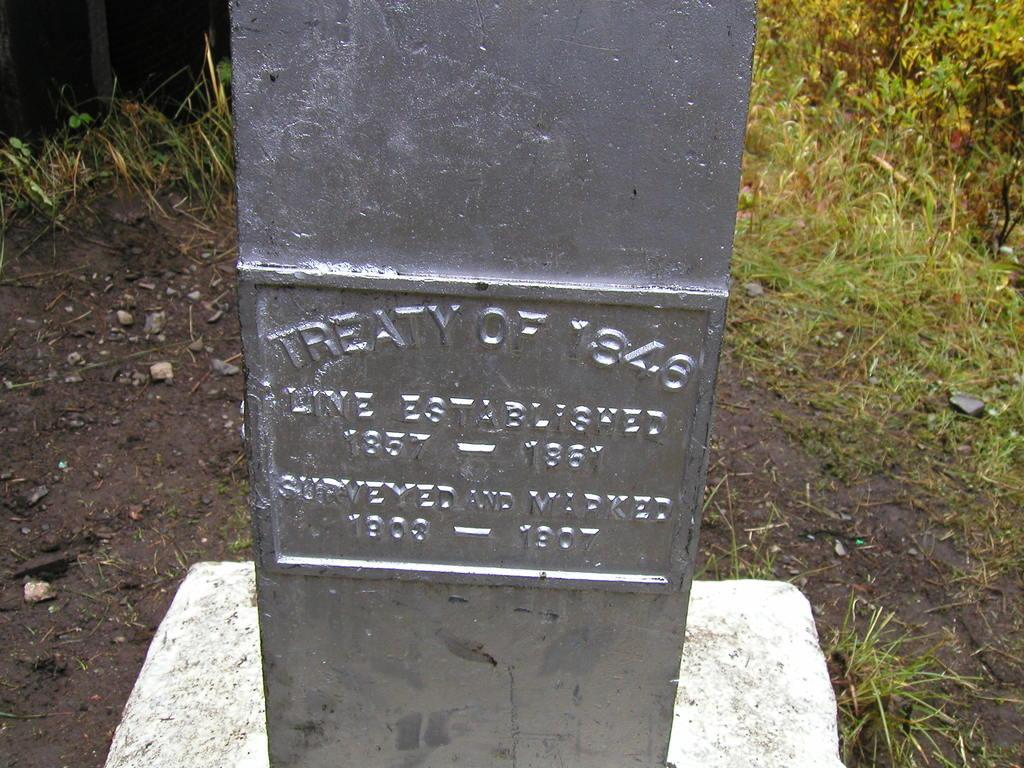What is the main subject in the image? There is a memorial in the image. What type of natural environment can be seen in the background of the image? There is grass visible in the background of the image. Where is the shop located in the image? There is no shop present in the image. What type of crack can be seen on the memorial in the image? There is no crack visible on the memorial in the image. 